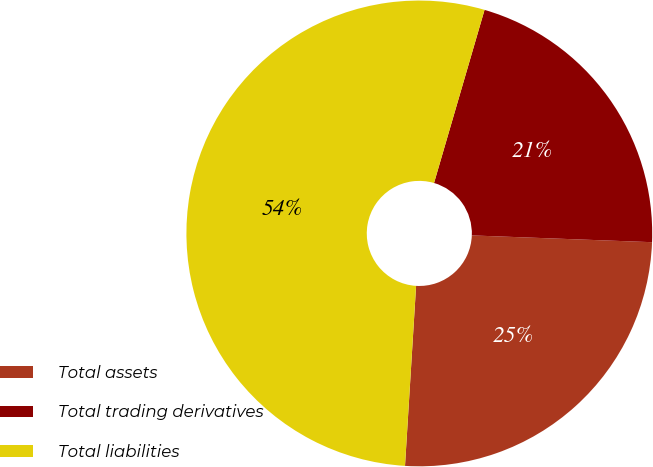<chart> <loc_0><loc_0><loc_500><loc_500><pie_chart><fcel>Total assets<fcel>Total trading derivatives<fcel>Total liabilities<nl><fcel>25.38%<fcel>21.08%<fcel>53.54%<nl></chart> 